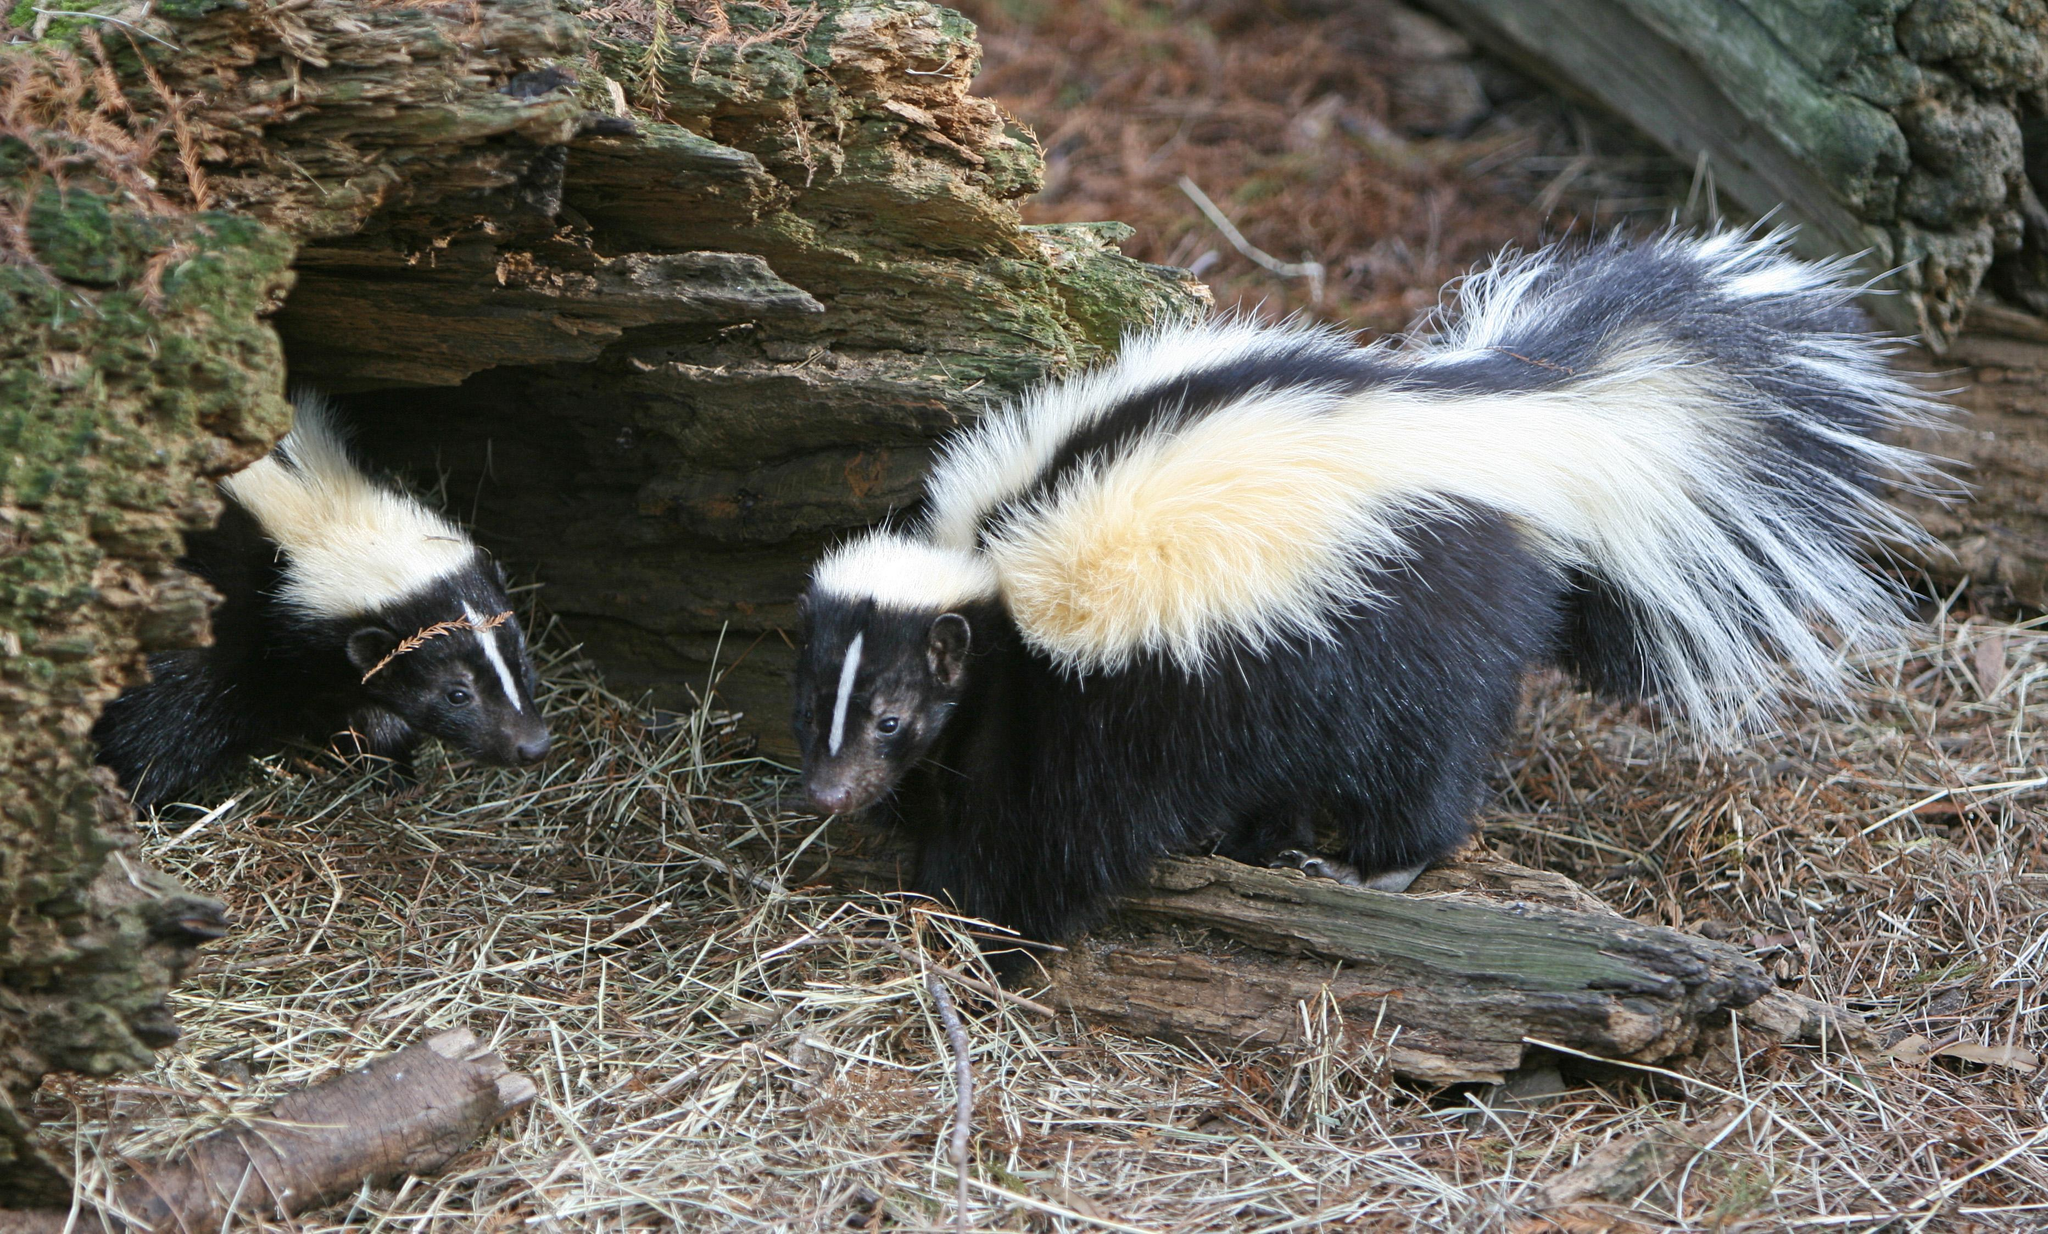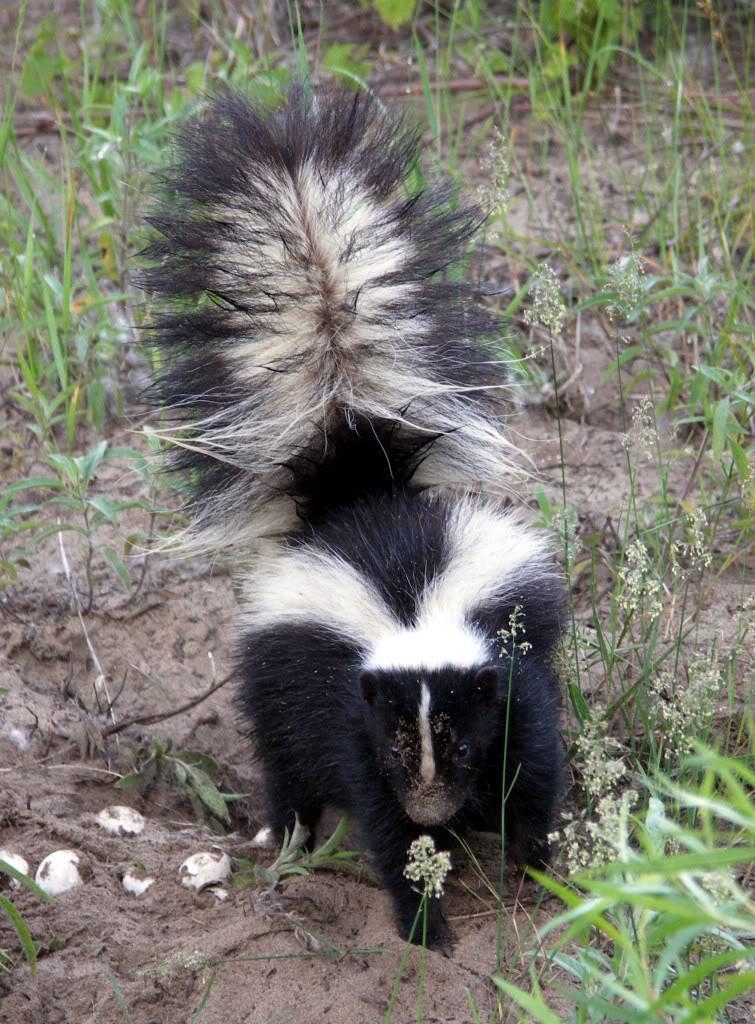The first image is the image on the left, the second image is the image on the right. For the images shown, is this caption "One of the images has a skunk along with a an animal that is not a skunk." true? Answer yes or no. No. The first image is the image on the left, the second image is the image on the right. Examine the images to the left and right. Is the description "In one of the images an animal can be seen eating dog food." accurate? Answer yes or no. No. 